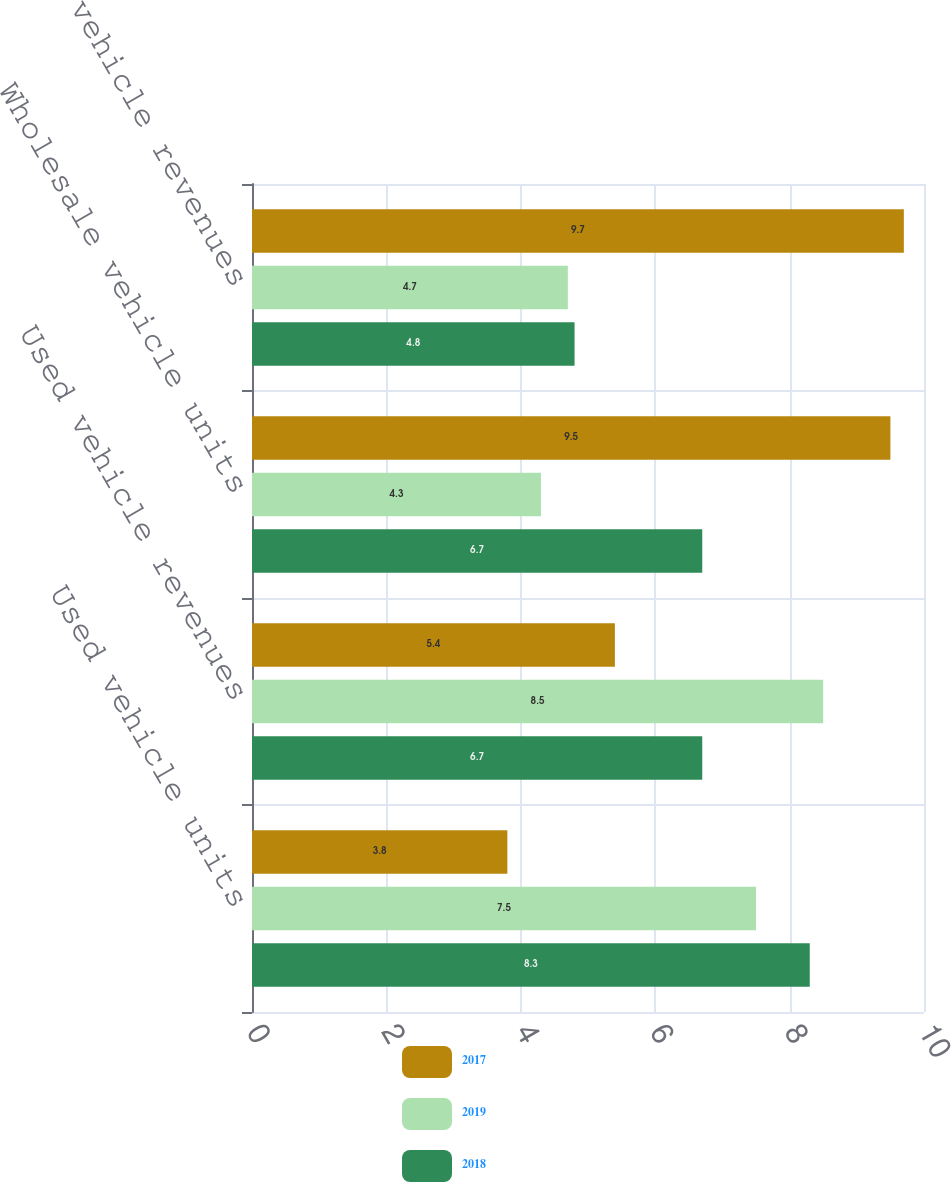<chart> <loc_0><loc_0><loc_500><loc_500><stacked_bar_chart><ecel><fcel>Used vehicle units<fcel>Used vehicle revenues<fcel>Wholesale vehicle units<fcel>Wholesale vehicle revenues<nl><fcel>2017<fcel>3.8<fcel>5.4<fcel>9.5<fcel>9.7<nl><fcel>2019<fcel>7.5<fcel>8.5<fcel>4.3<fcel>4.7<nl><fcel>2018<fcel>8.3<fcel>6.7<fcel>6.7<fcel>4.8<nl></chart> 